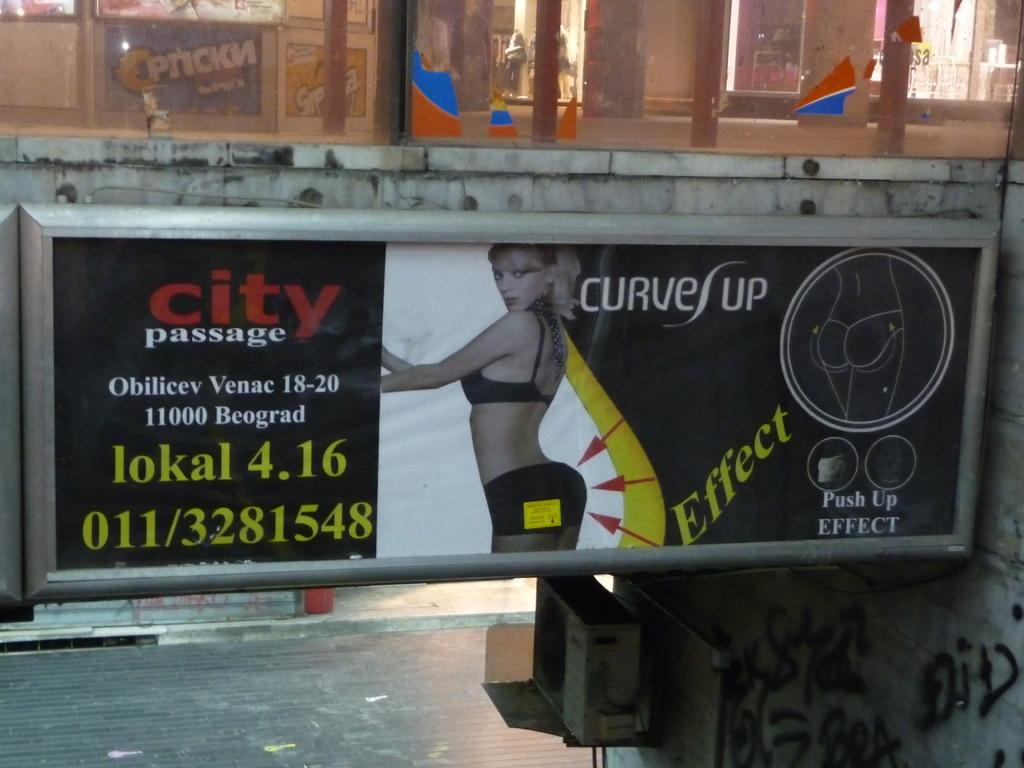What is featured on the poster in the image? The poster contains an image of a girl standing. What type of structure is visible in the image? There is a glass window in the image. What surface is present in the image? There is a floor in the image. What type of information is present in the image? There is printed text in the image. Is there a ghost visible in the image? No, there is no ghost present in the image. What type of boundary is depicted in the image? There is no boundary depicted in the image. 